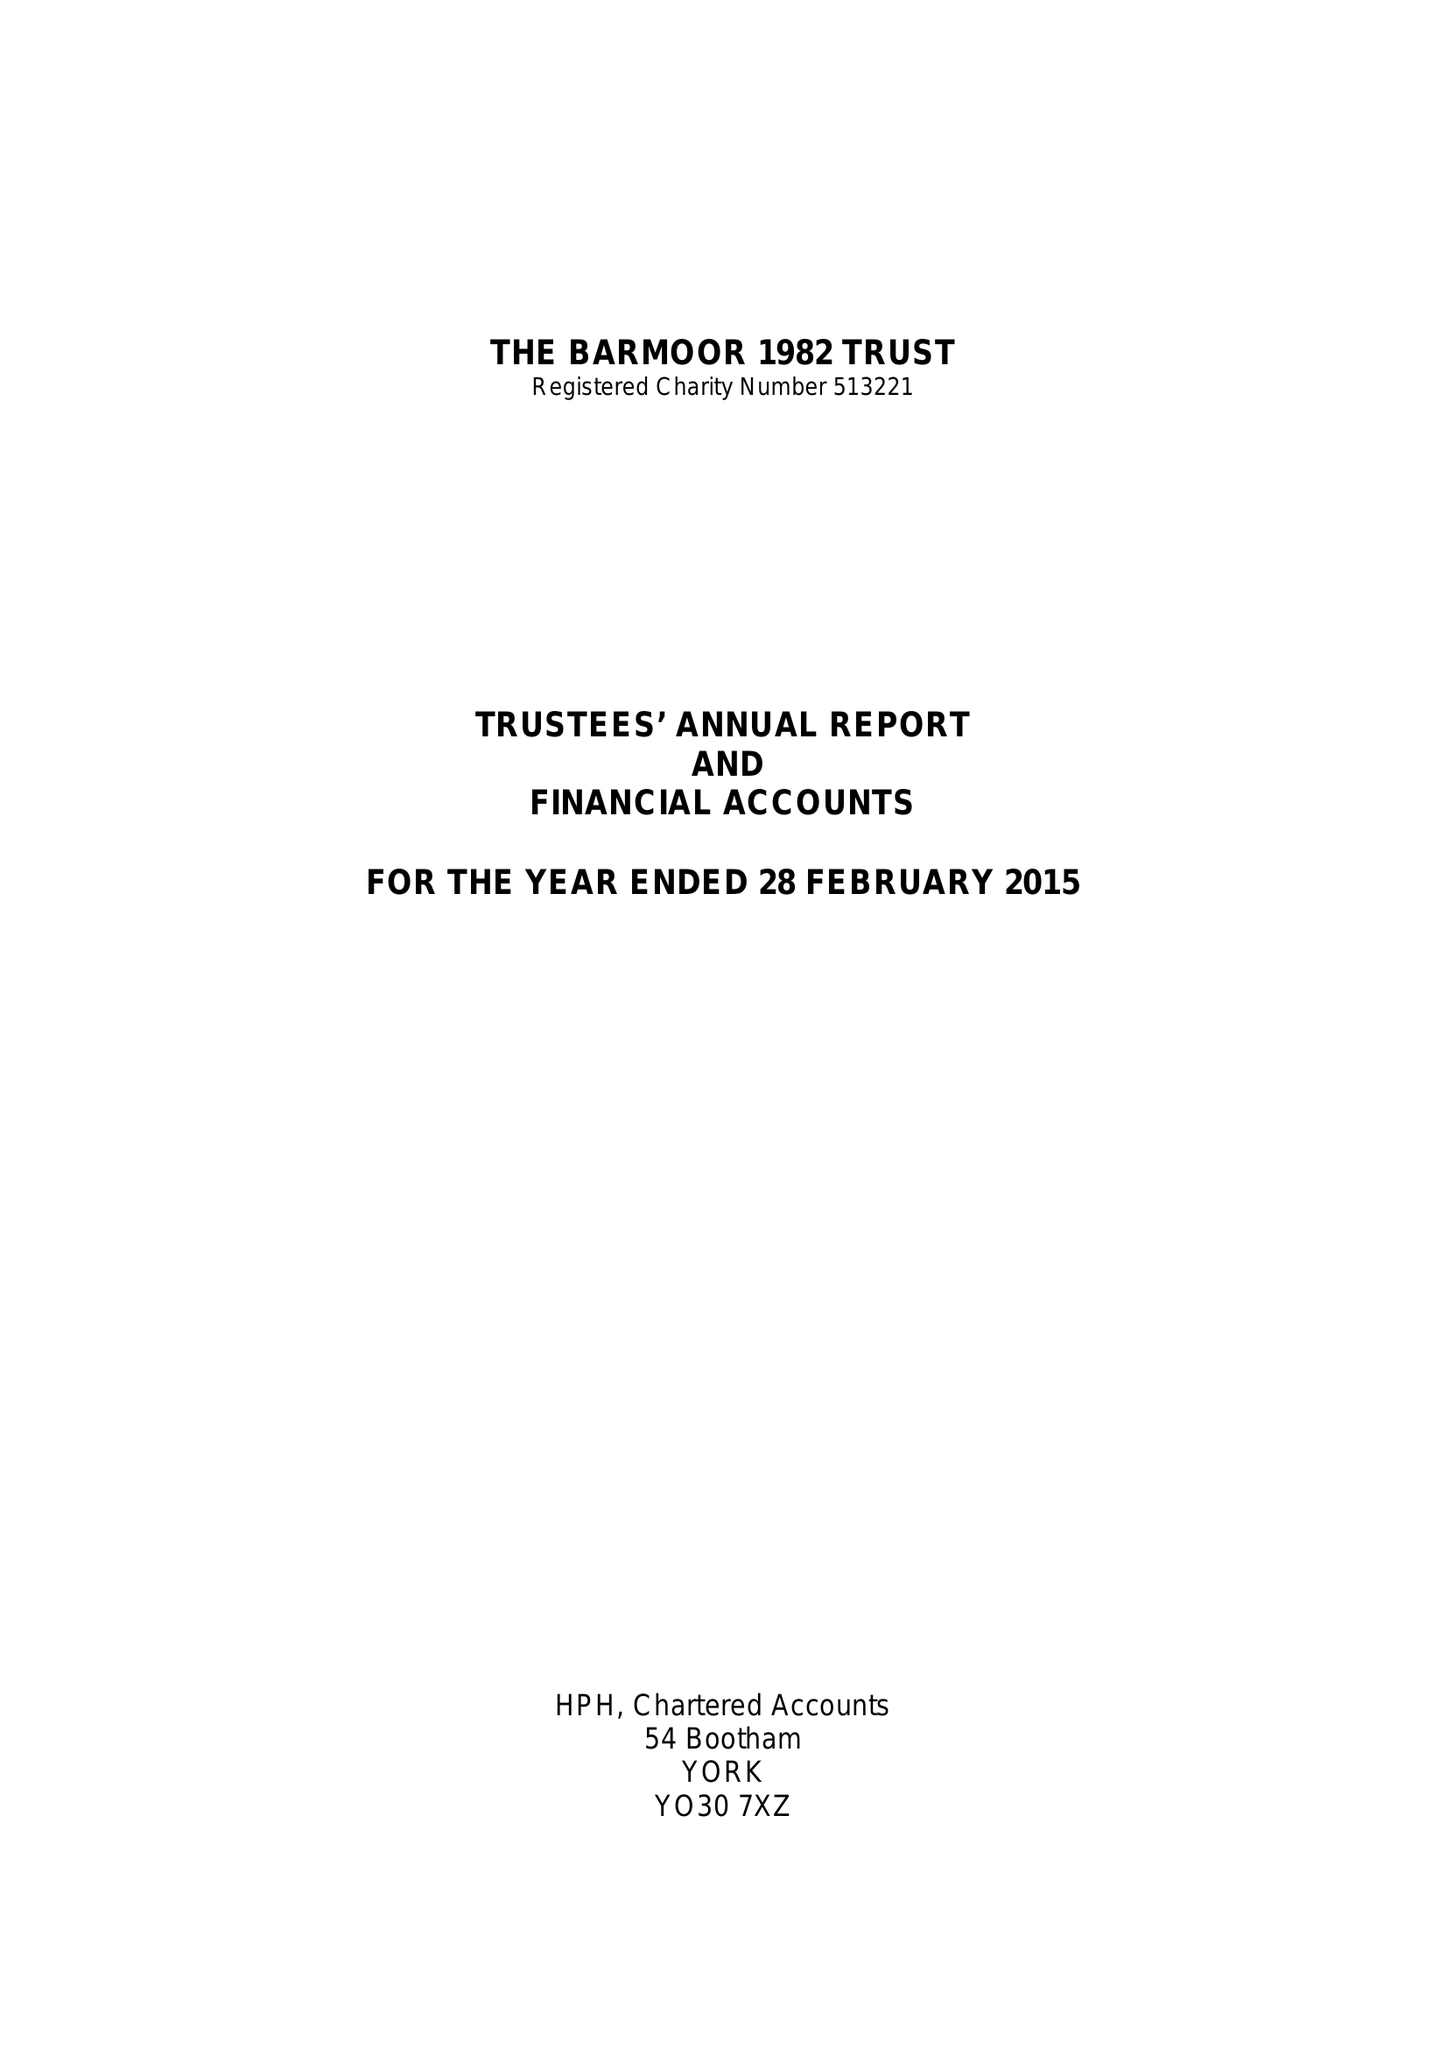What is the value for the charity_number?
Answer the question using a single word or phrase. 513221 